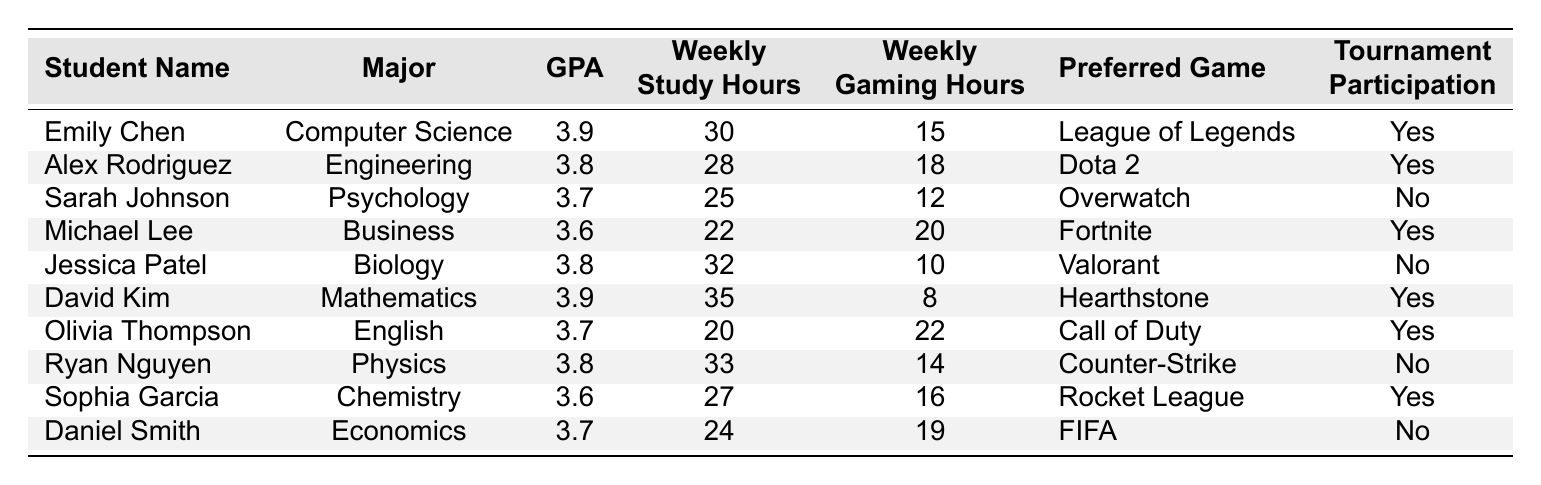What is the highest GPA among the students? The table lists the GPAs for each student, with Emily Chen and David Kim both having the highest GPA of 3.9.
Answer: 3.9 How many students study more than 30 hours a week? The students who study more than 30 hours a week are Emily Chen (30), Jessica Patel (32), and David Kim (35). That's a total of 3 students.
Answer: 3 Who has the lowest gaming hours and what is the time? David Kim has the lowest gaming hours, at 8 hours per week.
Answer: 8 Is there a student who studies less than 25 hours a week and participates in tournaments? Michael Lee studies 22 hours a week and participates in tournaments. So yes, there is such a student.
Answer: Yes What is the difference in weekly study hours between Alex Rodriguez and Sophia Garcia? Alex Rodriguez studies 28 hours while Sophia Garcia studies 27 hours. The difference is 28 - 27 = 1 hour.
Answer: 1 hour What is the average gaming hours for all students in the table? The total gaming hours sum to (15 + 18 + 12 + 20 + 10 + 8 + 22 + 14 + 16 + 19) =  182. There are 10 students, so the average gaming hours is 182 / 10 = 18.2 hours.
Answer: 18.2 Which major has a student with the highest gaming hours? Olivia Thompson in English has the highest gaming hours at 22 hours per week.
Answer: English How many students have a GPA of 3.7 or higher? Looking at the data, there are six students with GPAs of 3.7 (Sarah Johnson, Ryan Nguyen, Daniel Smith) or higher (Emily Chen, Alex Rodriguez, David Kim).
Answer: 6 What is the total study hours of students participating in tournaments? The study hours of students participating in tournaments are 30 (Emily) + 28 (Alex) + 22 (Michael) + 35 (David) + 20 (Olivia) + 27 (Sophia) = 162 hours.
Answer: 162 Which student has the most gaming hours and what is the preferred game? Olivia Thompson has the most gaming hours at 22, and her preferred game is Call of Duty.
Answer: Call of Duty 